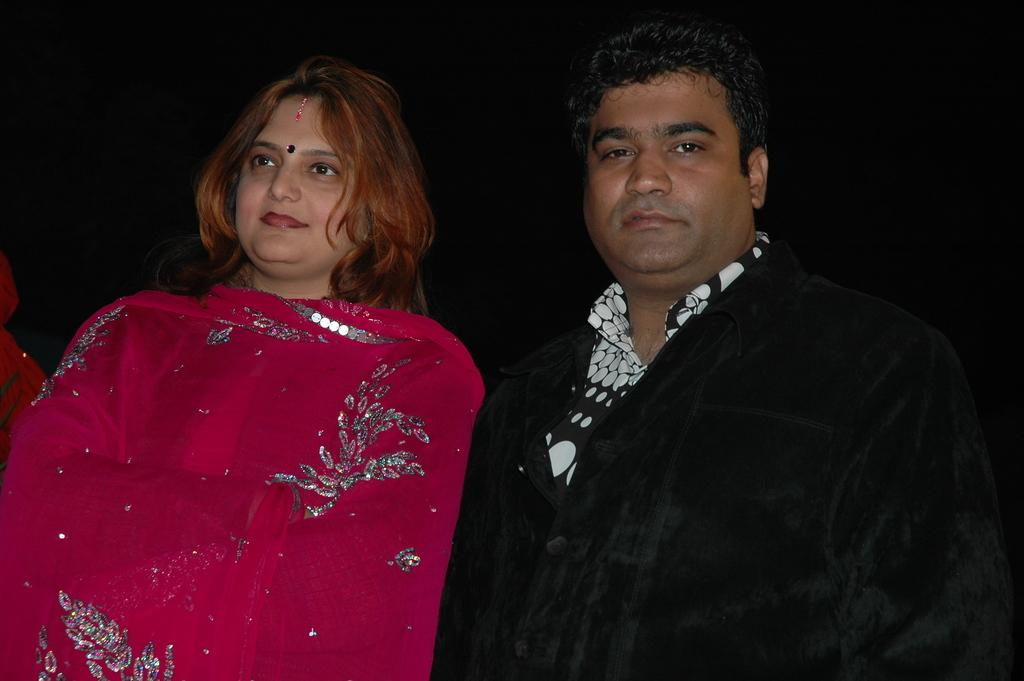How many people are in the image? There are two people in the image, a man and a woman. What are the man and woman doing in the image? The man and woman are standing together. Can you describe the relationship between the man and woman in the image? The facts provided do not give enough information to determine the relationship between the man and woman. What type of bee can be seen buzzing around the queen in the image? There is no queen or bee present in the image; it features a man and a woman standing together. 